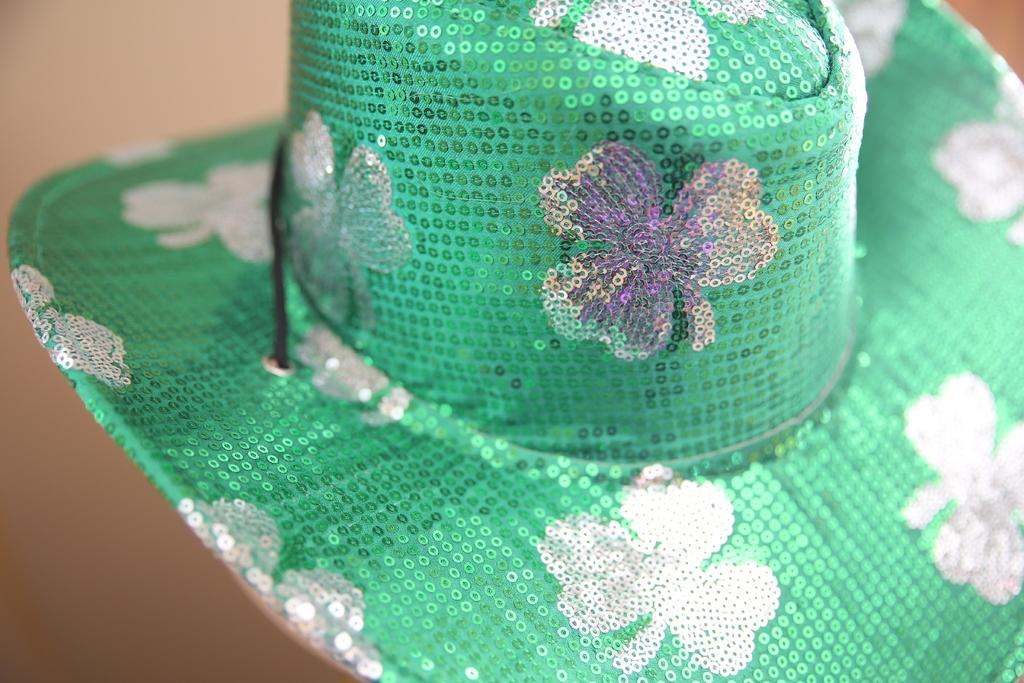What object can be seen in the image? There is a hat in the image. What design is featured on the hat? The hat has a print of flowers. How would you describe the background of the image? The background of the image is blurry. Can you see the kitty's tongue sticking out in the image? There is no kitty present in the image, so it is not possible to see its tongue. 